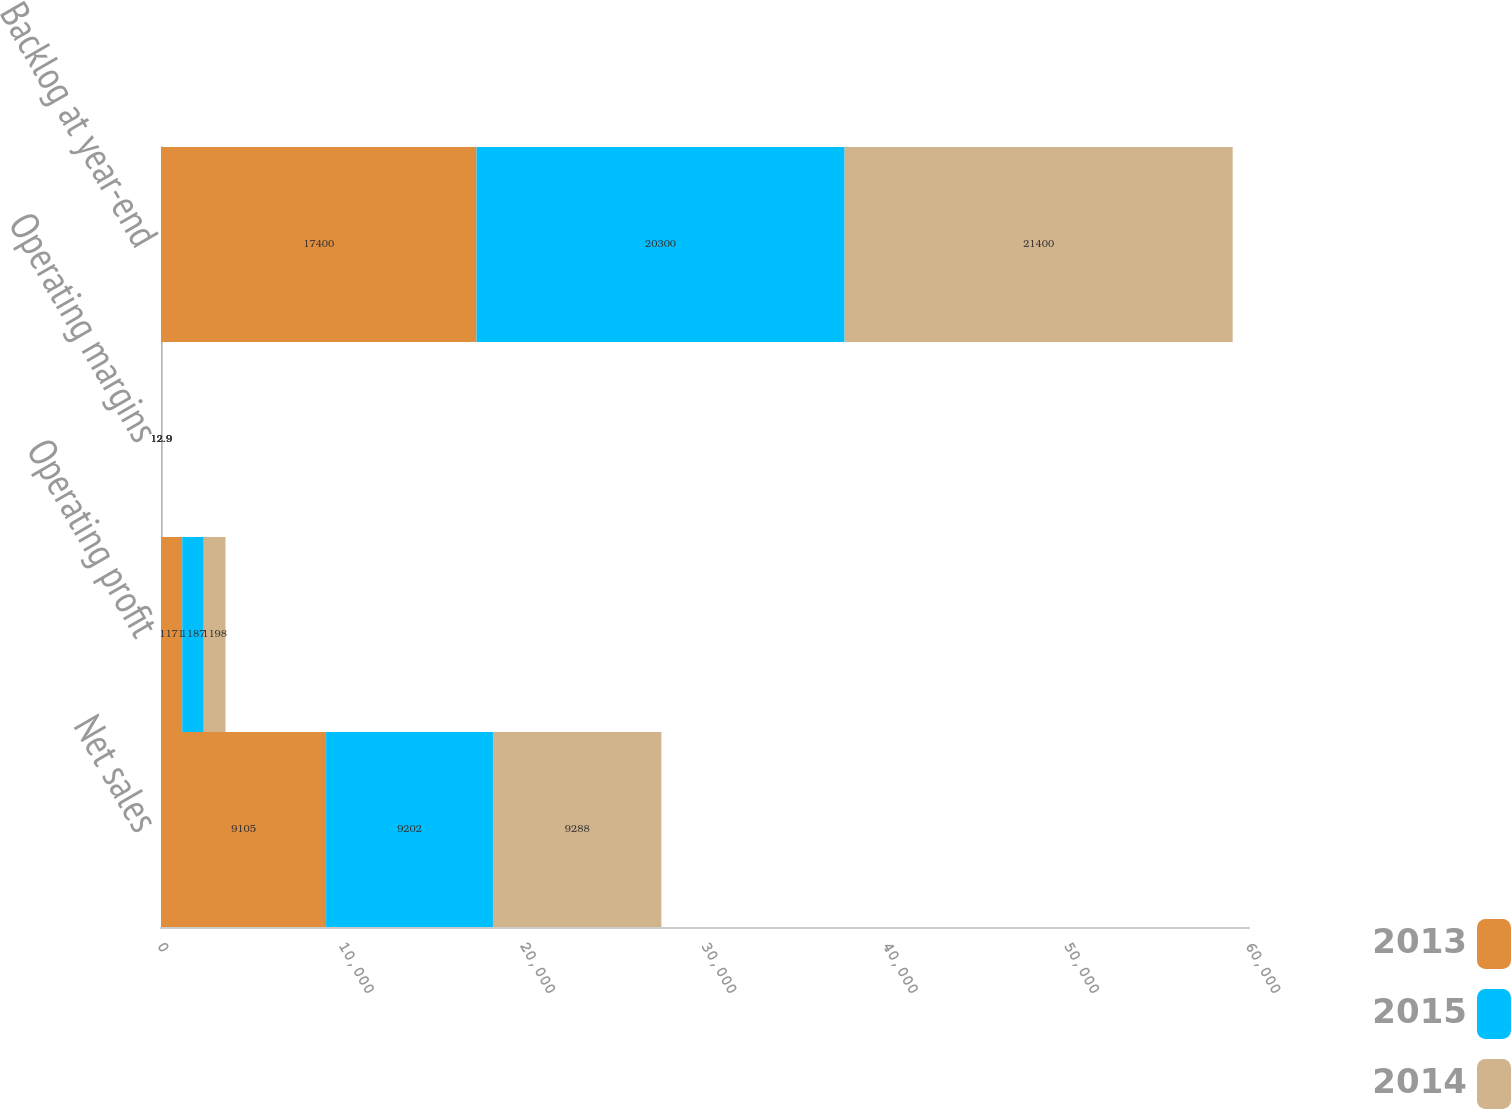<chart> <loc_0><loc_0><loc_500><loc_500><stacked_bar_chart><ecel><fcel>Net sales<fcel>Operating profit<fcel>Operating margins<fcel>Backlog at year-end<nl><fcel>2013<fcel>9105<fcel>1171<fcel>12.9<fcel>17400<nl><fcel>2015<fcel>9202<fcel>1187<fcel>12.9<fcel>20300<nl><fcel>2014<fcel>9288<fcel>1198<fcel>12.9<fcel>21400<nl></chart> 